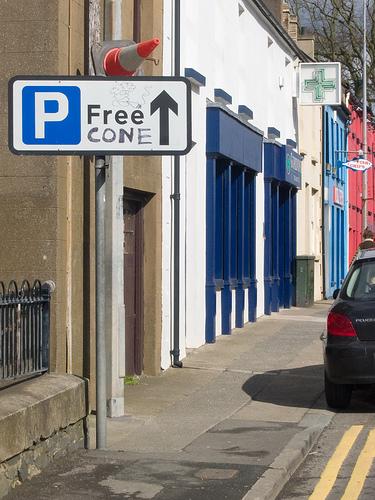Is a shadow cast?
Be succinct. Yes. What kind of hat is a cone shaped like?
Write a very short answer. Witch hat. What is the sign pointing to?
Answer briefly. Cone. What letters are on the sign?
Write a very short answer. P. How many signs are there?
Write a very short answer. 2. 